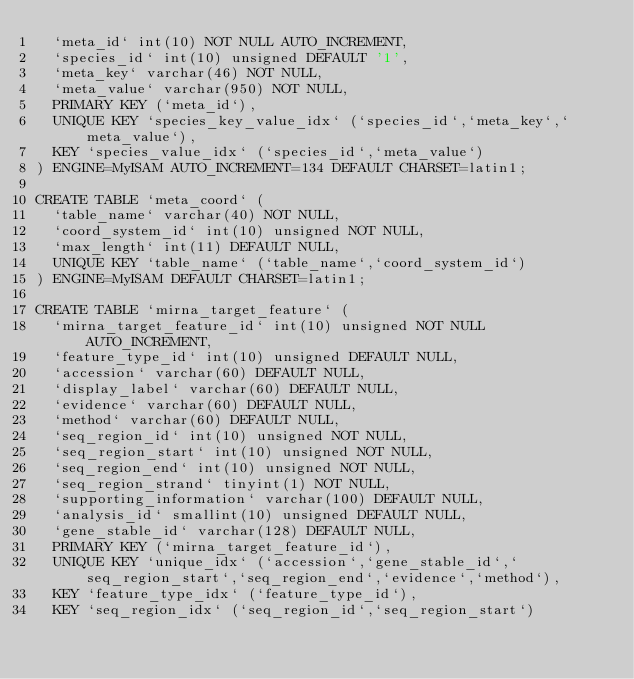<code> <loc_0><loc_0><loc_500><loc_500><_SQL_>  `meta_id` int(10) NOT NULL AUTO_INCREMENT,
  `species_id` int(10) unsigned DEFAULT '1',
  `meta_key` varchar(46) NOT NULL,
  `meta_value` varchar(950) NOT NULL,
  PRIMARY KEY (`meta_id`),
  UNIQUE KEY `species_key_value_idx` (`species_id`,`meta_key`,`meta_value`),
  KEY `species_value_idx` (`species_id`,`meta_value`)
) ENGINE=MyISAM AUTO_INCREMENT=134 DEFAULT CHARSET=latin1;

CREATE TABLE `meta_coord` (
  `table_name` varchar(40) NOT NULL,
  `coord_system_id` int(10) unsigned NOT NULL,
  `max_length` int(11) DEFAULT NULL,
  UNIQUE KEY `table_name` (`table_name`,`coord_system_id`)
) ENGINE=MyISAM DEFAULT CHARSET=latin1;

CREATE TABLE `mirna_target_feature` (
  `mirna_target_feature_id` int(10) unsigned NOT NULL AUTO_INCREMENT,
  `feature_type_id` int(10) unsigned DEFAULT NULL,
  `accession` varchar(60) DEFAULT NULL,
  `display_label` varchar(60) DEFAULT NULL,
  `evidence` varchar(60) DEFAULT NULL,
  `method` varchar(60) DEFAULT NULL,
  `seq_region_id` int(10) unsigned NOT NULL,
  `seq_region_start` int(10) unsigned NOT NULL,
  `seq_region_end` int(10) unsigned NOT NULL,
  `seq_region_strand` tinyint(1) NOT NULL,
  `supporting_information` varchar(100) DEFAULT NULL,
  `analysis_id` smallint(10) unsigned DEFAULT NULL,
  `gene_stable_id` varchar(128) DEFAULT NULL,
  PRIMARY KEY (`mirna_target_feature_id`),
  UNIQUE KEY `unique_idx` (`accession`,`gene_stable_id`,`seq_region_start`,`seq_region_end`,`evidence`,`method`),
  KEY `feature_type_idx` (`feature_type_id`),
  KEY `seq_region_idx` (`seq_region_id`,`seq_region_start`)</code> 